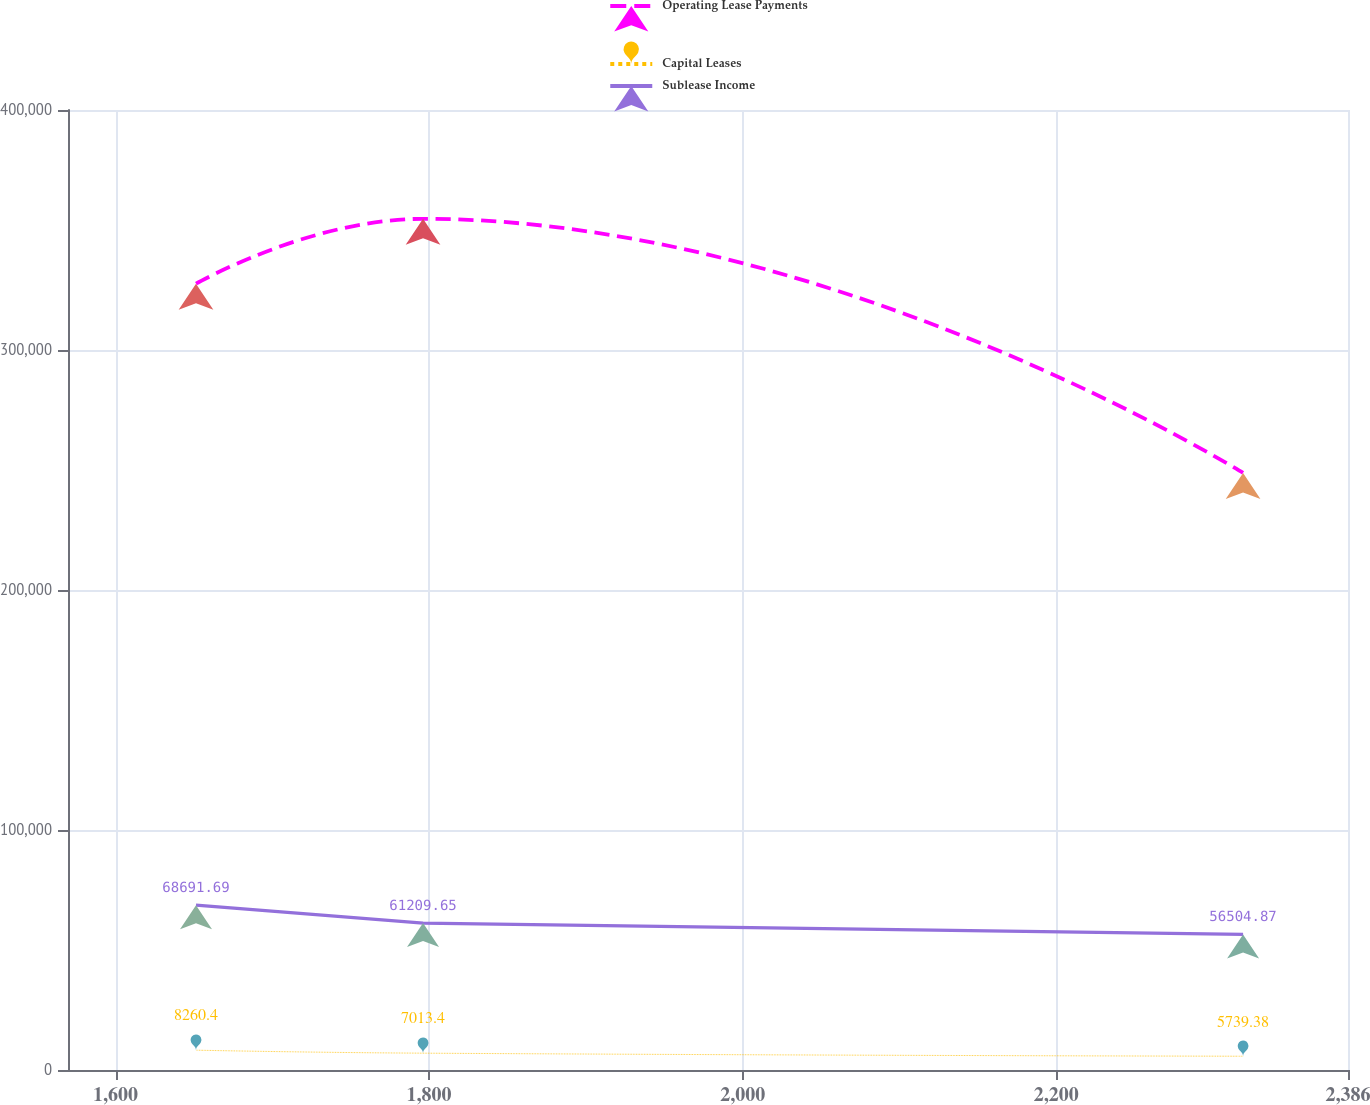Convert chart. <chart><loc_0><loc_0><loc_500><loc_500><line_chart><ecel><fcel>Operating Lease Payments<fcel>Capital Leases<fcel>Sublease Income<nl><fcel>1651.33<fcel>327631<fcel>8260.4<fcel>68691.7<nl><fcel>1796.12<fcel>354655<fcel>7013.4<fcel>61209.7<nl><fcel>2319.09<fcel>248755<fcel>5739.38<fcel>56504.9<nl><fcel>2393.36<fcel>214208<fcel>4659.91<fcel>49179.1<nl><fcel>2467.63<fcel>234710<fcel>3801.45<fcel>41323.4<nl></chart> 